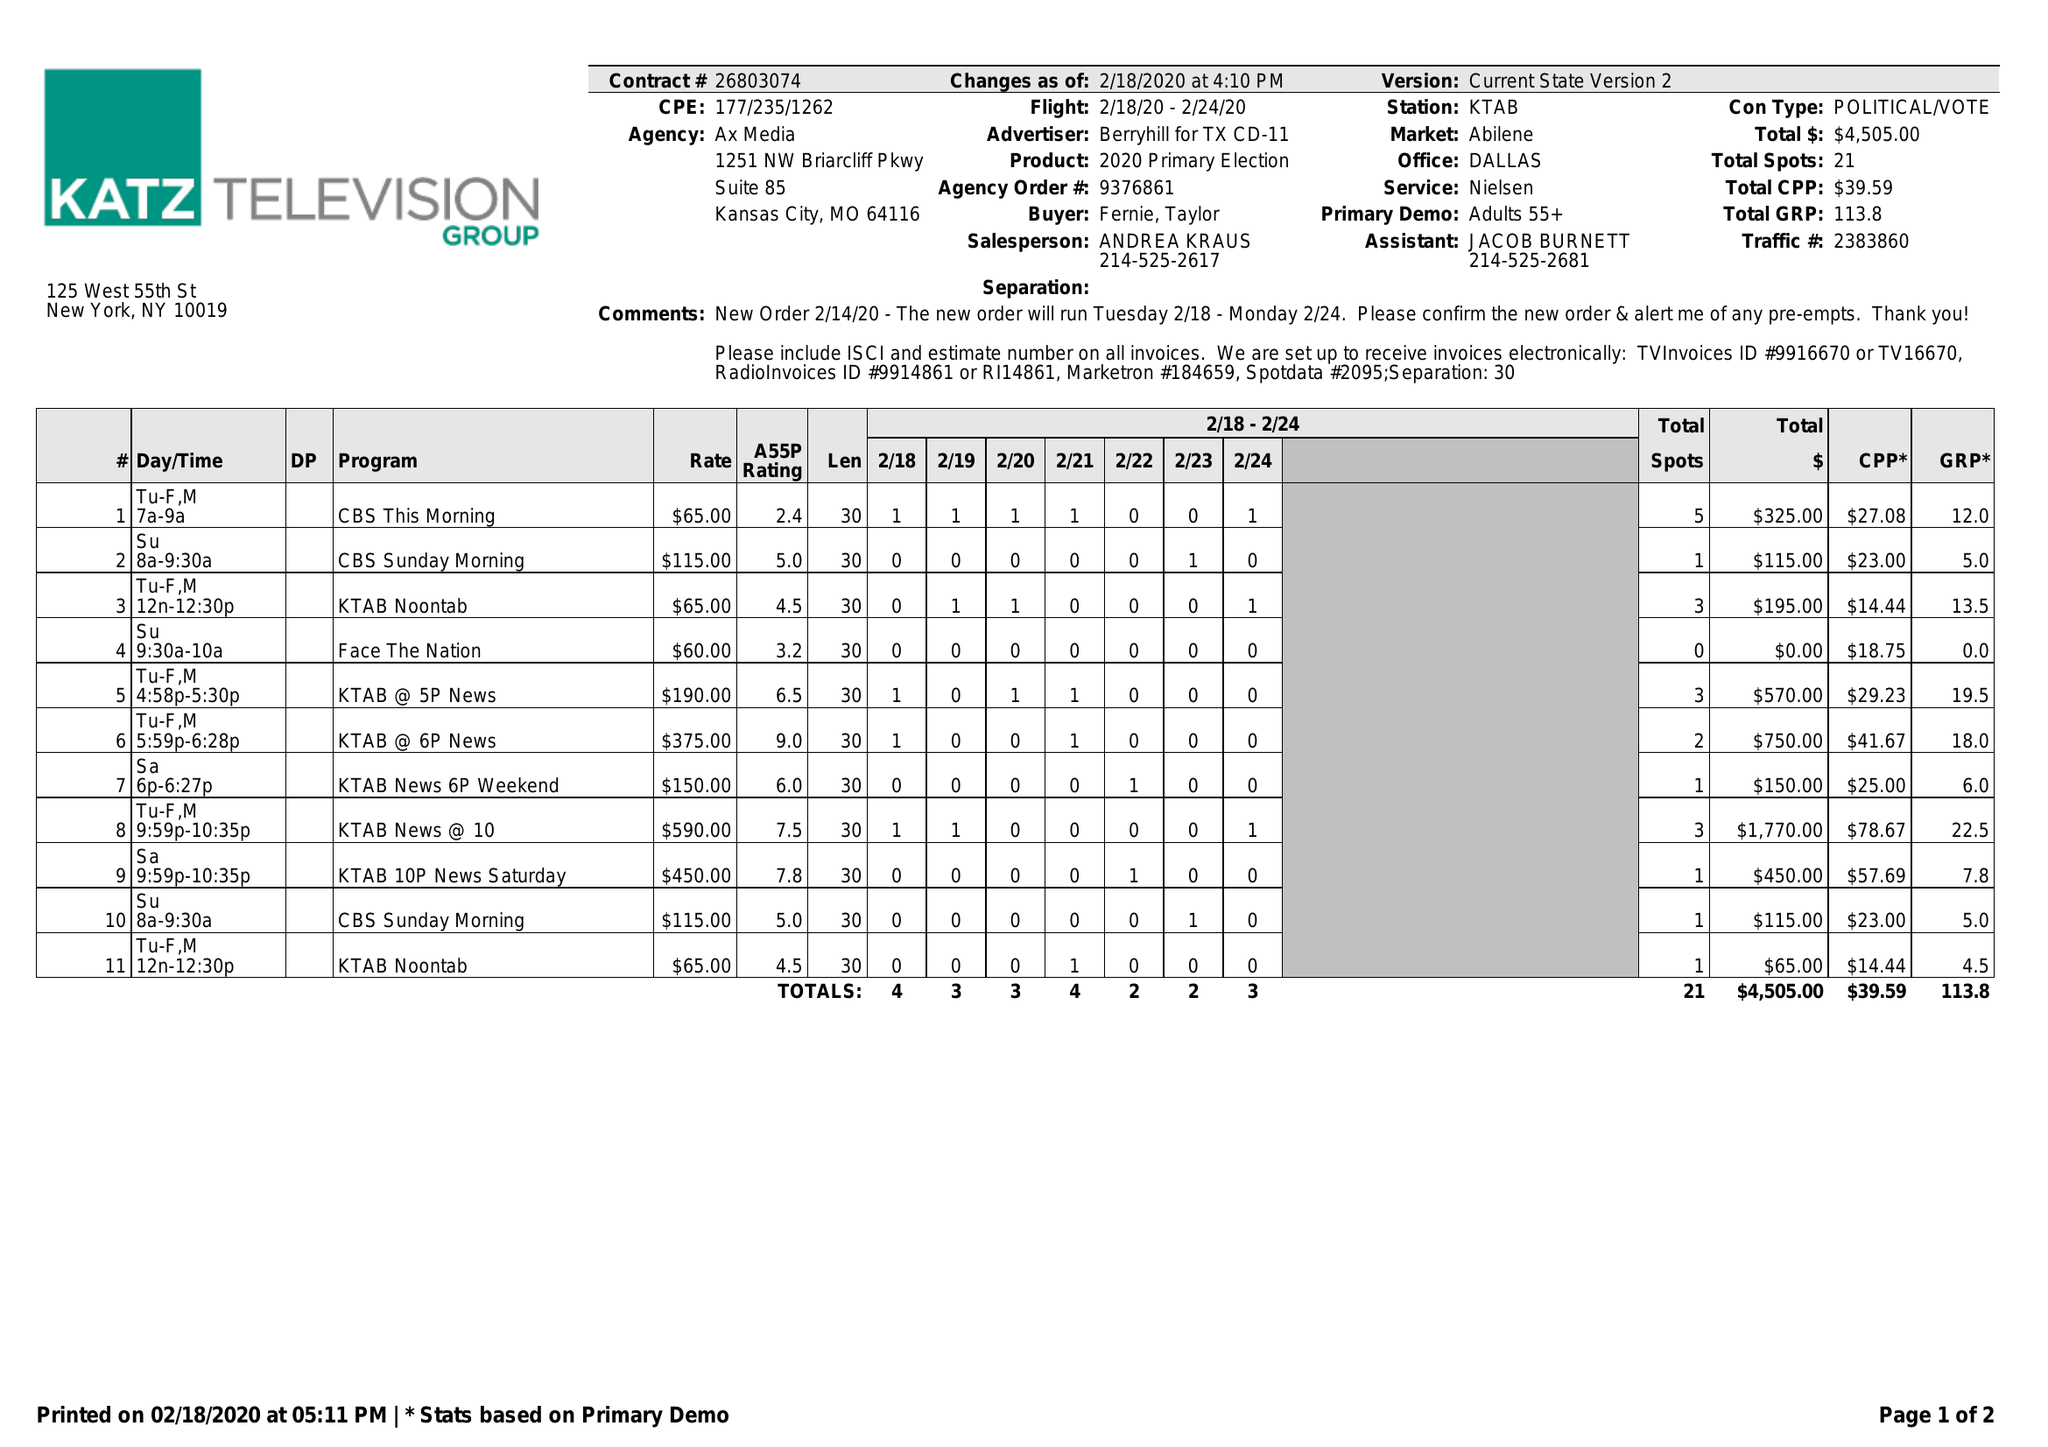What is the value for the flight_from?
Answer the question using a single word or phrase. 02/18/20 